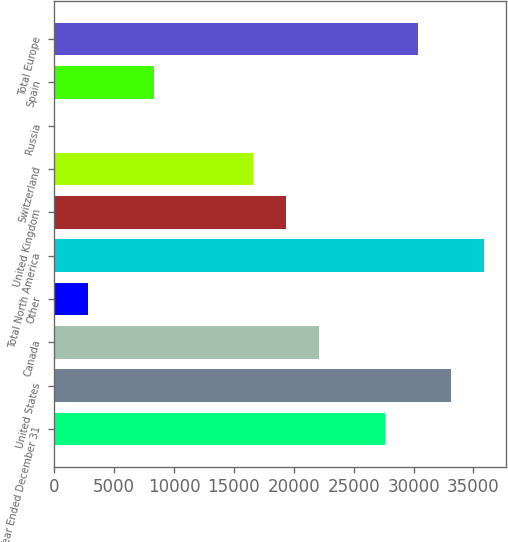<chart> <loc_0><loc_0><loc_500><loc_500><bar_chart><fcel>Year Ended December 31<fcel>United States<fcel>Canada<fcel>Other<fcel>Total North America<fcel>United Kingdom<fcel>Switzerland<fcel>Russia<fcel>Spain<fcel>Total Europe<nl><fcel>27623<fcel>33141.8<fcel>22104.2<fcel>2788.4<fcel>35901.2<fcel>19344.8<fcel>16585.4<fcel>29<fcel>8307.2<fcel>30382.4<nl></chart> 